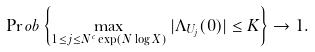Convert formula to latex. <formula><loc_0><loc_0><loc_500><loc_500>\Pr o b \left \{ \max _ { 1 \leq j \leq N ^ { c } \exp ( N \log X ) } | \Lambda _ { U _ { j } } ( 0 ) | \leq K \right \} \to 1 .</formula> 